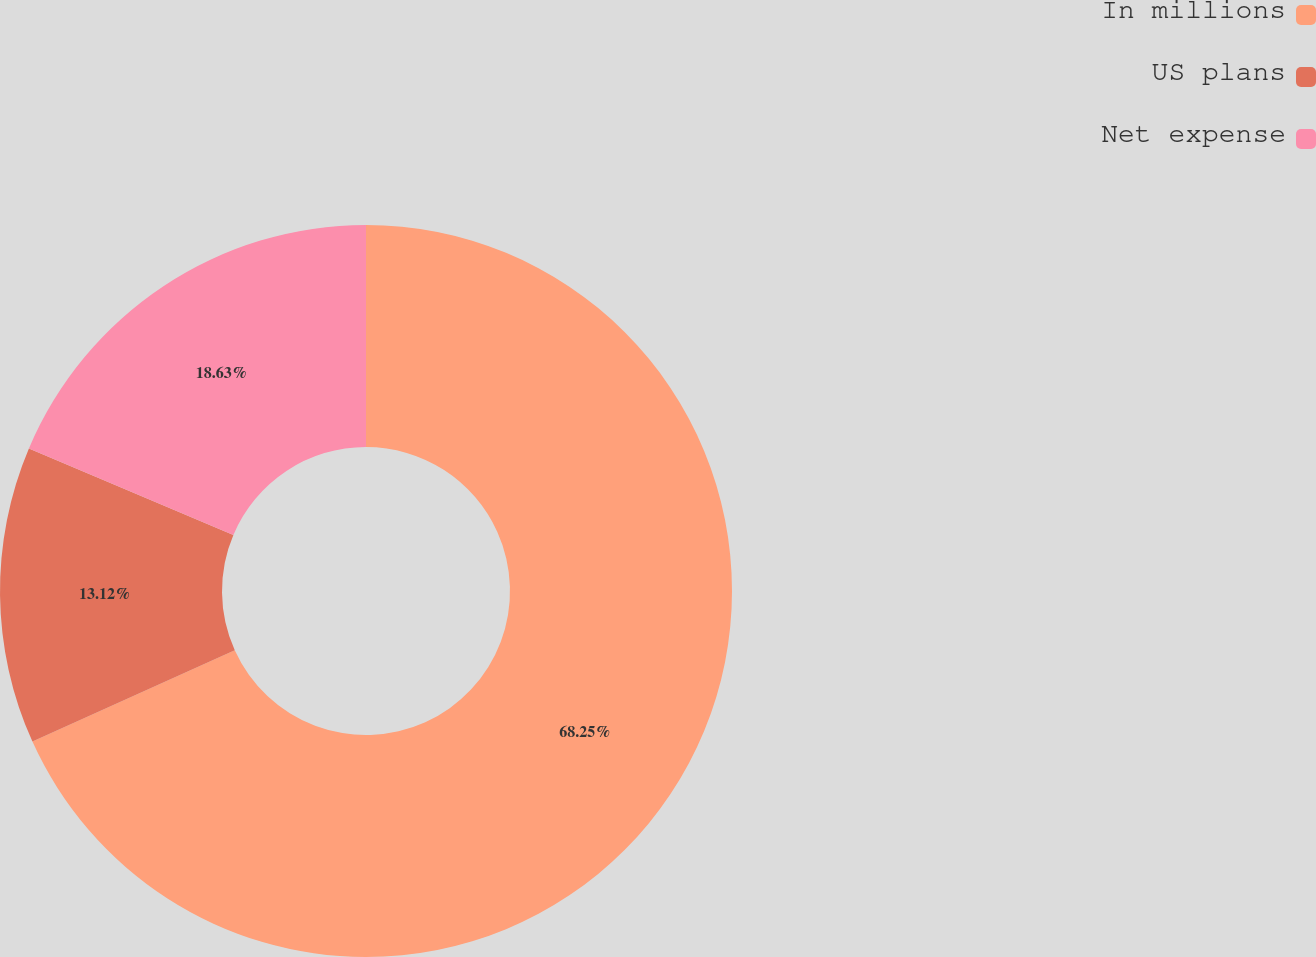Convert chart. <chart><loc_0><loc_0><loc_500><loc_500><pie_chart><fcel>In millions<fcel>US plans<fcel>Net expense<nl><fcel>68.25%<fcel>13.12%<fcel>18.63%<nl></chart> 